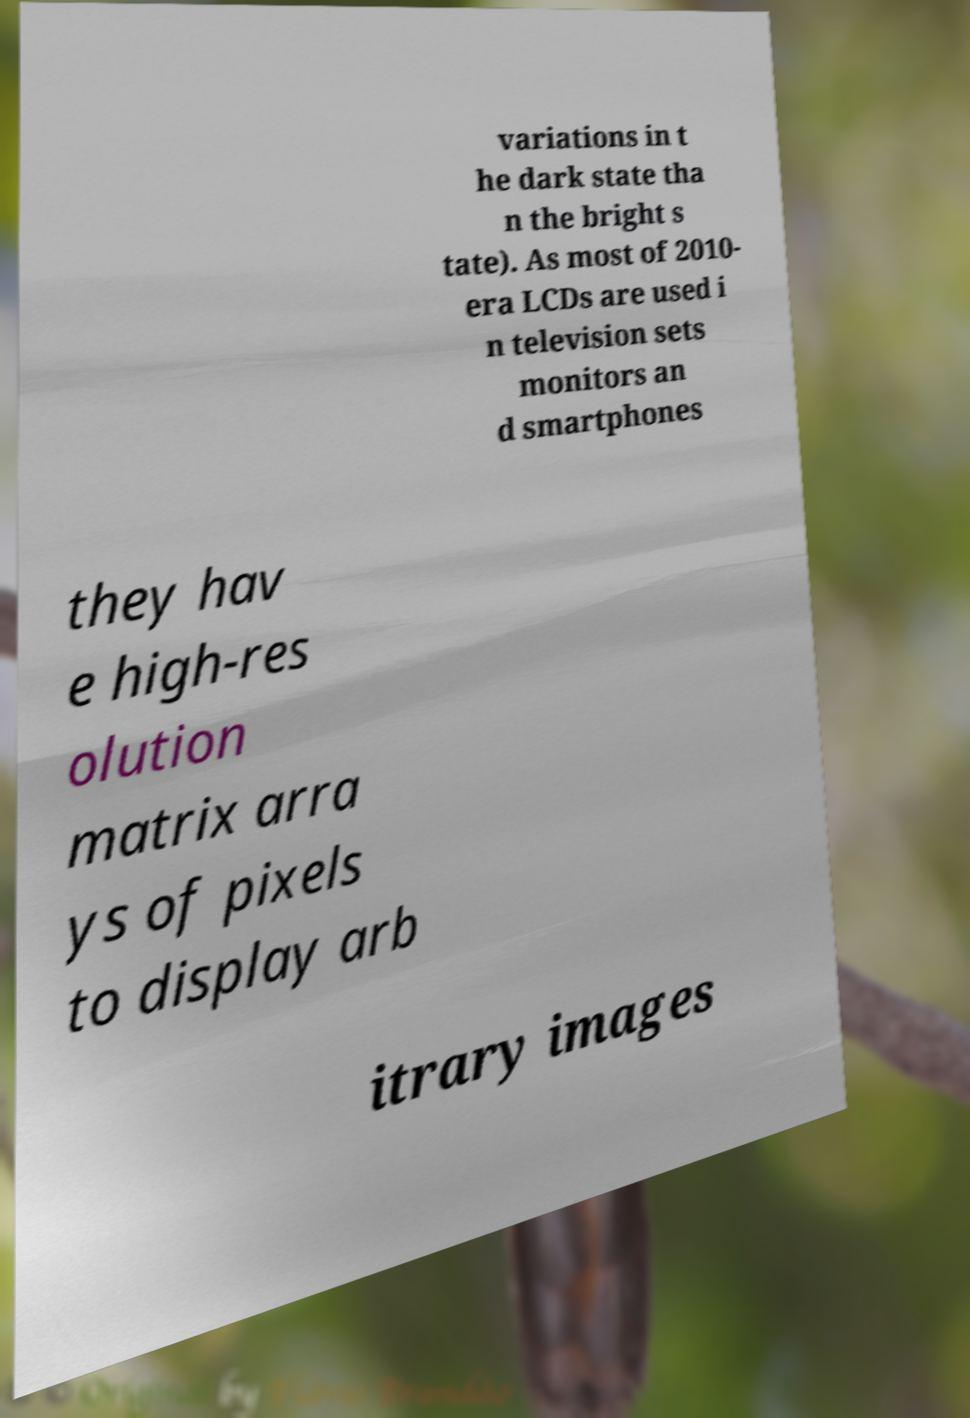Can you accurately transcribe the text from the provided image for me? variations in t he dark state tha n the bright s tate). As most of 2010- era LCDs are used i n television sets monitors an d smartphones they hav e high-res olution matrix arra ys of pixels to display arb itrary images 